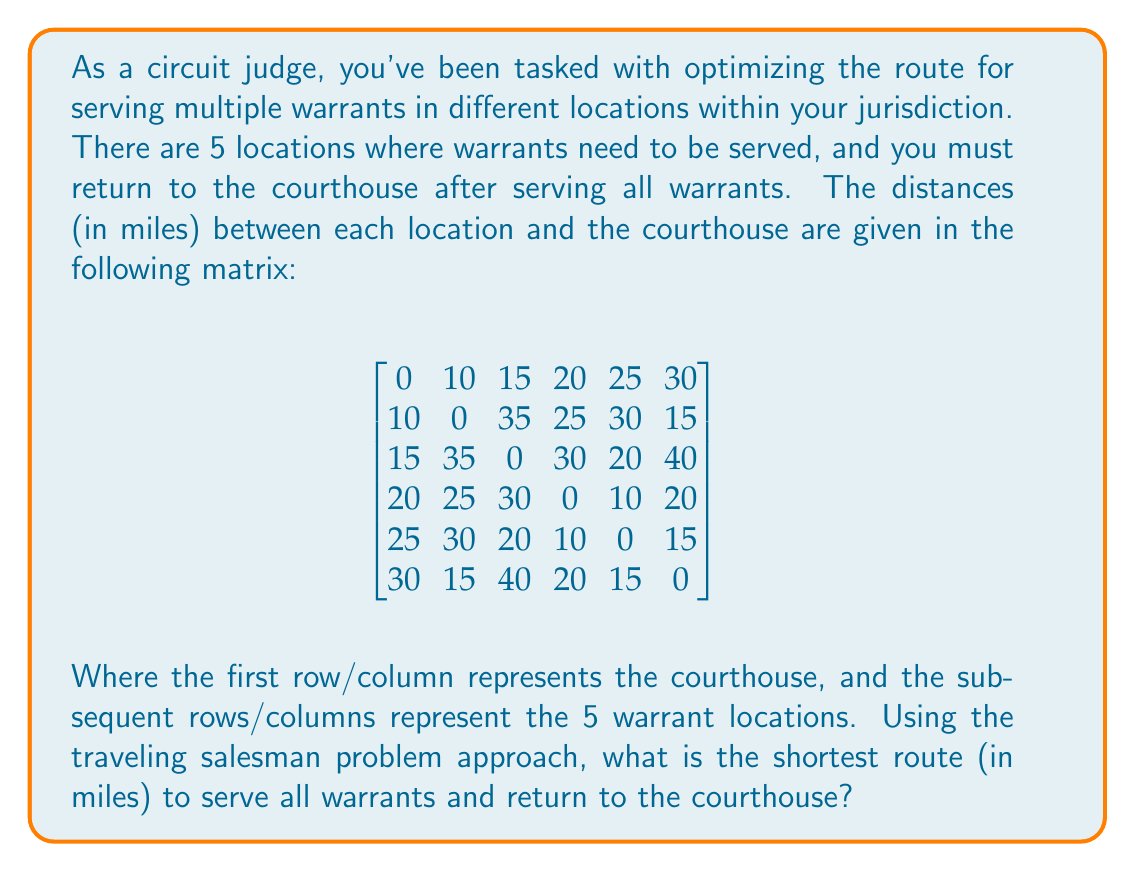What is the answer to this math problem? To solve this traveling salesman problem, we'll use the nearest neighbor heuristic, which is a simple but effective method for finding a reasonably good solution. Here's the step-by-step process:

1) Start at the courthouse (node 0).

2) Find the nearest unvisited location:
   - Nearest to 0 is 1 (10 miles)
   
3) Move to location 1, then find the nearest unvisited location:
   - Nearest to 1 is 5 (15 miles)
   
4) Move to location 5, then find the nearest unvisited location:
   - Nearest to 5 is 4 (15 miles)
   
5) Move to location 4, then find the nearest unvisited location:
   - Nearest to 4 is 3 (10 miles)
   
6) Move to location 3, then visit the last remaining location:
   - Move to 2 (30 miles)
   
7) Return to the courthouse from location 2:
   - Distance from 2 to 0 is 15 miles

Now, let's calculate the total distance:
$$\text{Total Distance} = 10 + 15 + 15 + 10 + 30 + 15 = 95 \text{ miles}$$

This route (0 → 1 → 5 → 4 → 3 → 2 → 0) provides a solution to the traveling salesman problem, though it may not be the absolute optimal solution. Finding the guaranteed optimal solution would require more complex algorithms like branch and bound or dynamic programming, which are beyond the scope of this problem.
Answer: The shortest route to serve all warrants and return to the courthouse, using the nearest neighbor heuristic, is 95 miles. 